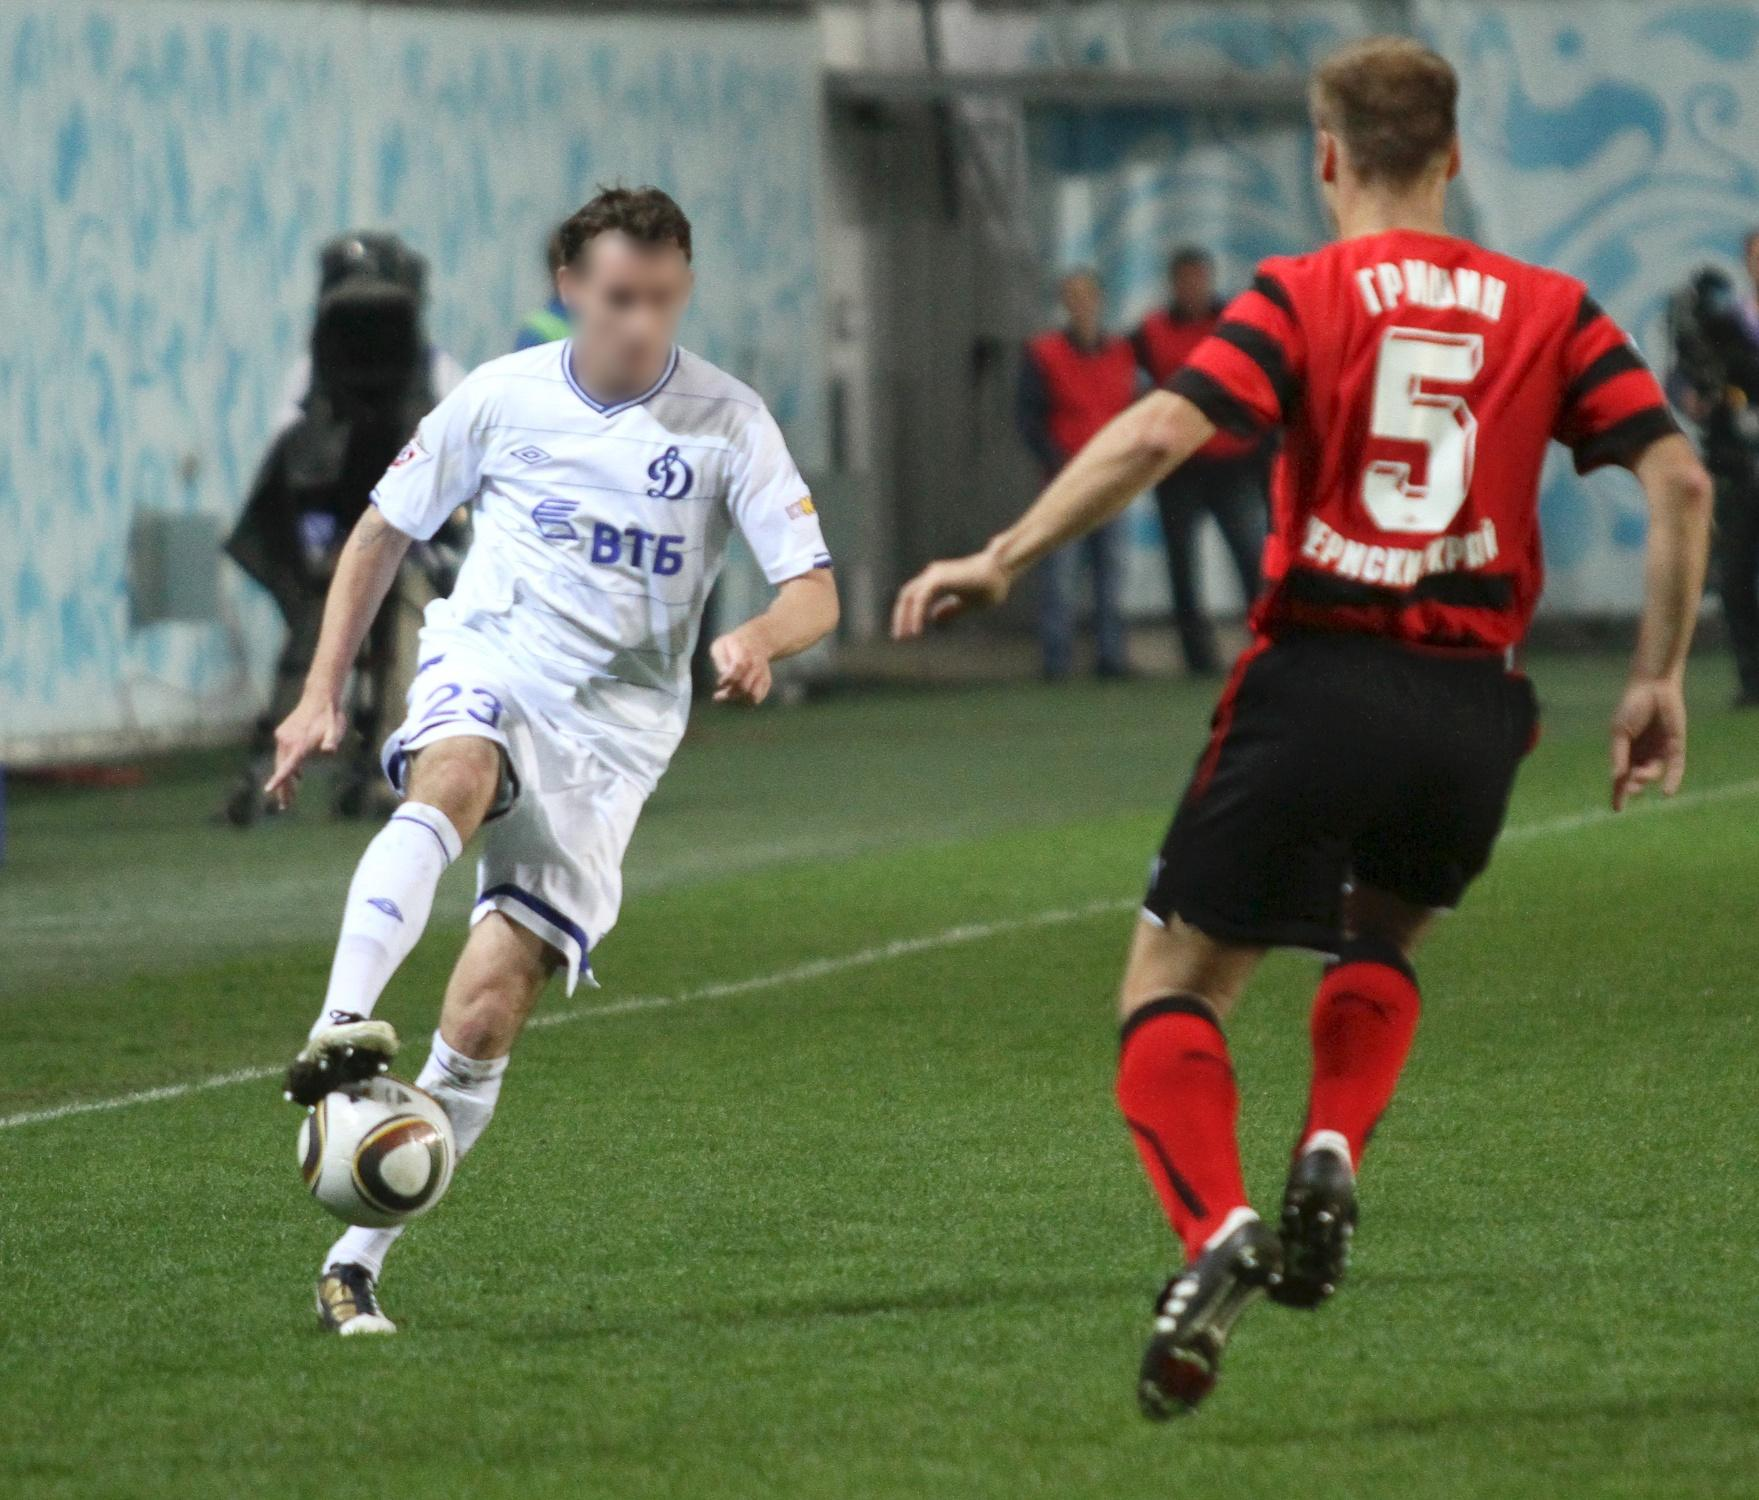If you could imagine an alternate universe scenario involving this exact moment, how would it unfold? In an alternate universe, this intense moment unfolds in an intergalactic soccer arena. The players aren't just humans but represent various alien species, each bringing unique abilities and skills to the game. The player in the white jersey hails from a planet with lower gravity, allowing for incredibly agile and high jumps, while the player in the red and black jersey is from a world with superior strength. The stadium itself is a floating platform in deep space, with galaxies and stars as the backdrop. Spectators include diverse extraterrestrial beings, each displaying their excitement through a range of colors, lights, and sounds unique to their species. The ball is not just a regular soccer ball but a high-tech device that responds to the energy and intent of the players, changing its speed and trajectory dynamically. As the player in white makes contact with the ball, it begins to glow and accelerate, setting the stage for a breathtaking and otherworldly play. 